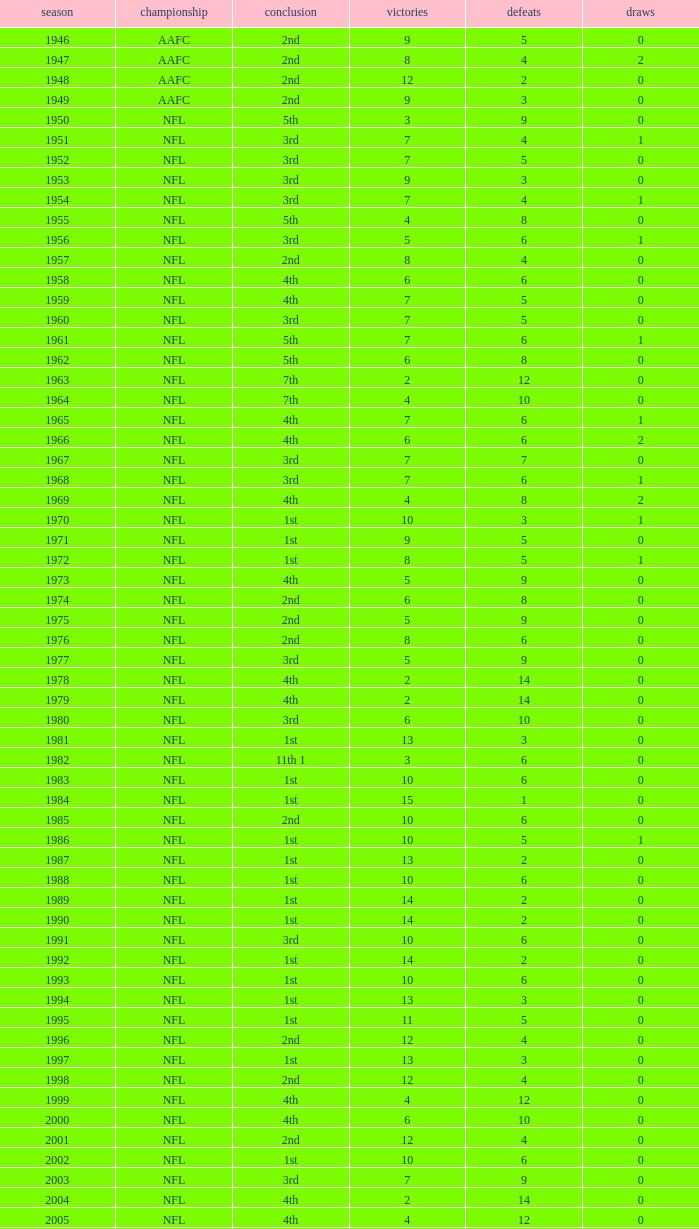What is the lowest number of ties in the NFL, with less than 2 losses and less than 15 wins? None. 